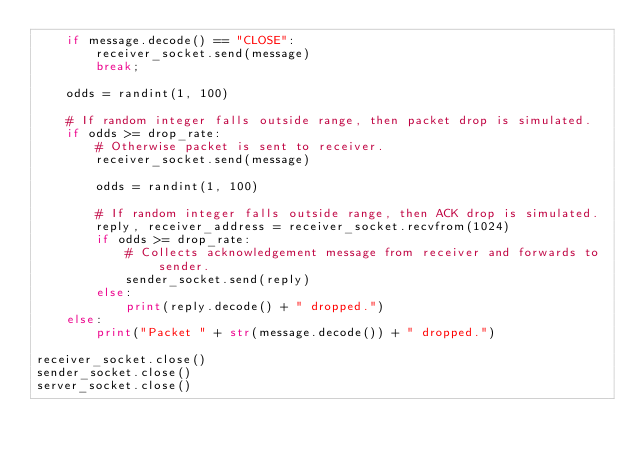<code> <loc_0><loc_0><loc_500><loc_500><_Python_>    if message.decode() == "CLOSE":
        receiver_socket.send(message)
        break;

    odds = randint(1, 100)

    # If random integer falls outside range, then packet drop is simulated.
    if odds >= drop_rate:
        # Otherwise packet is sent to receiver.
        receiver_socket.send(message)

        odds = randint(1, 100)

        # If random integer falls outside range, then ACK drop is simulated.
        reply, receiver_address = receiver_socket.recvfrom(1024)
        if odds >= drop_rate:
            # Collects acknowledgement message from receiver and forwards to sender.
            sender_socket.send(reply)
        else:
            print(reply.decode() + " dropped.")
    else:
        print("Packet " + str(message.decode()) + " dropped.")

receiver_socket.close()
sender_socket.close()
server_socket.close()</code> 